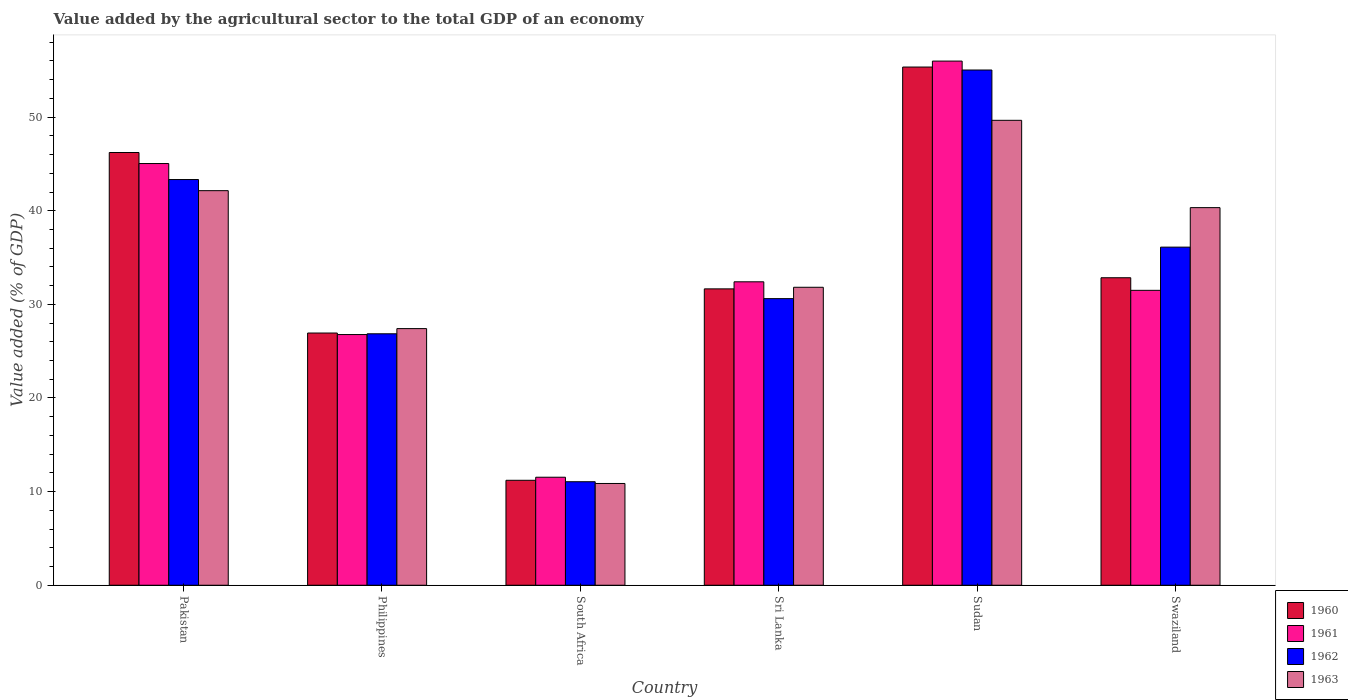What is the label of the 5th group of bars from the left?
Ensure brevity in your answer.  Sudan. What is the value added by the agricultural sector to the total GDP in 1960 in Swaziland?
Ensure brevity in your answer.  32.84. Across all countries, what is the maximum value added by the agricultural sector to the total GDP in 1962?
Offer a very short reply. 55.03. Across all countries, what is the minimum value added by the agricultural sector to the total GDP in 1960?
Make the answer very short. 11.21. In which country was the value added by the agricultural sector to the total GDP in 1960 maximum?
Give a very brief answer. Sudan. In which country was the value added by the agricultural sector to the total GDP in 1961 minimum?
Make the answer very short. South Africa. What is the total value added by the agricultural sector to the total GDP in 1962 in the graph?
Your response must be concise. 203.01. What is the difference between the value added by the agricultural sector to the total GDP in 1962 in Pakistan and that in Sri Lanka?
Provide a succinct answer. 12.72. What is the difference between the value added by the agricultural sector to the total GDP in 1962 in Pakistan and the value added by the agricultural sector to the total GDP in 1960 in Philippines?
Your response must be concise. 16.39. What is the average value added by the agricultural sector to the total GDP in 1960 per country?
Give a very brief answer. 34.04. What is the difference between the value added by the agricultural sector to the total GDP of/in 1963 and value added by the agricultural sector to the total GDP of/in 1960 in Philippines?
Keep it short and to the point. 0.47. What is the ratio of the value added by the agricultural sector to the total GDP in 1963 in South Africa to that in Sri Lanka?
Provide a short and direct response. 0.34. What is the difference between the highest and the second highest value added by the agricultural sector to the total GDP in 1962?
Offer a very short reply. 7.22. What is the difference between the highest and the lowest value added by the agricultural sector to the total GDP in 1961?
Your response must be concise. 44.45. In how many countries, is the value added by the agricultural sector to the total GDP in 1962 greater than the average value added by the agricultural sector to the total GDP in 1962 taken over all countries?
Make the answer very short. 3. Is the sum of the value added by the agricultural sector to the total GDP in 1963 in Pakistan and Sri Lanka greater than the maximum value added by the agricultural sector to the total GDP in 1961 across all countries?
Provide a short and direct response. Yes. Is it the case that in every country, the sum of the value added by the agricultural sector to the total GDP in 1963 and value added by the agricultural sector to the total GDP in 1962 is greater than the sum of value added by the agricultural sector to the total GDP in 1961 and value added by the agricultural sector to the total GDP in 1960?
Ensure brevity in your answer.  No. How many countries are there in the graph?
Keep it short and to the point. 6. Are the values on the major ticks of Y-axis written in scientific E-notation?
Make the answer very short. No. Does the graph contain any zero values?
Your response must be concise. No. How many legend labels are there?
Provide a short and direct response. 4. What is the title of the graph?
Keep it short and to the point. Value added by the agricultural sector to the total GDP of an economy. What is the label or title of the X-axis?
Keep it short and to the point. Country. What is the label or title of the Y-axis?
Your response must be concise. Value added (% of GDP). What is the Value added (% of GDP) of 1960 in Pakistan?
Provide a short and direct response. 46.22. What is the Value added (% of GDP) of 1961 in Pakistan?
Your answer should be compact. 45.04. What is the Value added (% of GDP) in 1962 in Pakistan?
Keep it short and to the point. 43.33. What is the Value added (% of GDP) in 1963 in Pakistan?
Keep it short and to the point. 42.15. What is the Value added (% of GDP) in 1960 in Philippines?
Offer a terse response. 26.94. What is the Value added (% of GDP) in 1961 in Philippines?
Keep it short and to the point. 26.78. What is the Value added (% of GDP) in 1962 in Philippines?
Make the answer very short. 26.86. What is the Value added (% of GDP) of 1963 in Philippines?
Your response must be concise. 27.41. What is the Value added (% of GDP) of 1960 in South Africa?
Your answer should be very brief. 11.21. What is the Value added (% of GDP) of 1961 in South Africa?
Give a very brief answer. 11.54. What is the Value added (% of GDP) in 1962 in South Africa?
Your answer should be very brief. 11.06. What is the Value added (% of GDP) in 1963 in South Africa?
Your answer should be very brief. 10.87. What is the Value added (% of GDP) of 1960 in Sri Lanka?
Make the answer very short. 31.66. What is the Value added (% of GDP) of 1961 in Sri Lanka?
Give a very brief answer. 32.41. What is the Value added (% of GDP) of 1962 in Sri Lanka?
Offer a very short reply. 30.61. What is the Value added (% of GDP) of 1963 in Sri Lanka?
Offer a very short reply. 31.83. What is the Value added (% of GDP) of 1960 in Sudan?
Provide a short and direct response. 55.35. What is the Value added (% of GDP) in 1961 in Sudan?
Make the answer very short. 55.99. What is the Value added (% of GDP) in 1962 in Sudan?
Your answer should be very brief. 55.03. What is the Value added (% of GDP) in 1963 in Sudan?
Ensure brevity in your answer.  49.66. What is the Value added (% of GDP) of 1960 in Swaziland?
Make the answer very short. 32.84. What is the Value added (% of GDP) of 1961 in Swaziland?
Ensure brevity in your answer.  31.5. What is the Value added (% of GDP) in 1962 in Swaziland?
Your answer should be very brief. 36.11. What is the Value added (% of GDP) of 1963 in Swaziland?
Offer a terse response. 40.33. Across all countries, what is the maximum Value added (% of GDP) in 1960?
Keep it short and to the point. 55.35. Across all countries, what is the maximum Value added (% of GDP) of 1961?
Give a very brief answer. 55.99. Across all countries, what is the maximum Value added (% of GDP) in 1962?
Provide a succinct answer. 55.03. Across all countries, what is the maximum Value added (% of GDP) of 1963?
Your response must be concise. 49.66. Across all countries, what is the minimum Value added (% of GDP) of 1960?
Ensure brevity in your answer.  11.21. Across all countries, what is the minimum Value added (% of GDP) in 1961?
Provide a succinct answer. 11.54. Across all countries, what is the minimum Value added (% of GDP) of 1962?
Your answer should be very brief. 11.06. Across all countries, what is the minimum Value added (% of GDP) of 1963?
Keep it short and to the point. 10.87. What is the total Value added (% of GDP) of 1960 in the graph?
Offer a very short reply. 204.22. What is the total Value added (% of GDP) in 1961 in the graph?
Keep it short and to the point. 203.26. What is the total Value added (% of GDP) in 1962 in the graph?
Provide a succinct answer. 203.01. What is the total Value added (% of GDP) of 1963 in the graph?
Provide a succinct answer. 202.25. What is the difference between the Value added (% of GDP) of 1960 in Pakistan and that in Philippines?
Your answer should be very brief. 19.28. What is the difference between the Value added (% of GDP) of 1961 in Pakistan and that in Philippines?
Offer a terse response. 18.27. What is the difference between the Value added (% of GDP) of 1962 in Pakistan and that in Philippines?
Give a very brief answer. 16.48. What is the difference between the Value added (% of GDP) in 1963 in Pakistan and that in Philippines?
Make the answer very short. 14.73. What is the difference between the Value added (% of GDP) of 1960 in Pakistan and that in South Africa?
Your response must be concise. 35.01. What is the difference between the Value added (% of GDP) in 1961 in Pakistan and that in South Africa?
Keep it short and to the point. 33.51. What is the difference between the Value added (% of GDP) of 1962 in Pakistan and that in South Africa?
Your answer should be very brief. 32.28. What is the difference between the Value added (% of GDP) in 1963 in Pakistan and that in South Africa?
Make the answer very short. 31.28. What is the difference between the Value added (% of GDP) in 1960 in Pakistan and that in Sri Lanka?
Ensure brevity in your answer.  14.56. What is the difference between the Value added (% of GDP) in 1961 in Pakistan and that in Sri Lanka?
Your answer should be compact. 12.63. What is the difference between the Value added (% of GDP) in 1962 in Pakistan and that in Sri Lanka?
Ensure brevity in your answer.  12.72. What is the difference between the Value added (% of GDP) in 1963 in Pakistan and that in Sri Lanka?
Offer a terse response. 10.32. What is the difference between the Value added (% of GDP) in 1960 in Pakistan and that in Sudan?
Offer a very short reply. -9.13. What is the difference between the Value added (% of GDP) of 1961 in Pakistan and that in Sudan?
Give a very brief answer. -10.94. What is the difference between the Value added (% of GDP) of 1962 in Pakistan and that in Sudan?
Your response must be concise. -11.7. What is the difference between the Value added (% of GDP) in 1963 in Pakistan and that in Sudan?
Make the answer very short. -7.51. What is the difference between the Value added (% of GDP) of 1960 in Pakistan and that in Swaziland?
Provide a short and direct response. 13.38. What is the difference between the Value added (% of GDP) in 1961 in Pakistan and that in Swaziland?
Your answer should be compact. 13.54. What is the difference between the Value added (% of GDP) in 1962 in Pakistan and that in Swaziland?
Make the answer very short. 7.22. What is the difference between the Value added (% of GDP) of 1963 in Pakistan and that in Swaziland?
Offer a terse response. 1.81. What is the difference between the Value added (% of GDP) of 1960 in Philippines and that in South Africa?
Your answer should be very brief. 15.73. What is the difference between the Value added (% of GDP) of 1961 in Philippines and that in South Africa?
Make the answer very short. 15.24. What is the difference between the Value added (% of GDP) of 1962 in Philippines and that in South Africa?
Provide a short and direct response. 15.8. What is the difference between the Value added (% of GDP) in 1963 in Philippines and that in South Africa?
Ensure brevity in your answer.  16.54. What is the difference between the Value added (% of GDP) of 1960 in Philippines and that in Sri Lanka?
Your answer should be very brief. -4.72. What is the difference between the Value added (% of GDP) in 1961 in Philippines and that in Sri Lanka?
Give a very brief answer. -5.63. What is the difference between the Value added (% of GDP) of 1962 in Philippines and that in Sri Lanka?
Your answer should be compact. -3.76. What is the difference between the Value added (% of GDP) in 1963 in Philippines and that in Sri Lanka?
Provide a succinct answer. -4.41. What is the difference between the Value added (% of GDP) of 1960 in Philippines and that in Sudan?
Provide a succinct answer. -28.41. What is the difference between the Value added (% of GDP) in 1961 in Philippines and that in Sudan?
Offer a terse response. -29.21. What is the difference between the Value added (% of GDP) of 1962 in Philippines and that in Sudan?
Give a very brief answer. -28.18. What is the difference between the Value added (% of GDP) in 1963 in Philippines and that in Sudan?
Provide a short and direct response. -22.25. What is the difference between the Value added (% of GDP) in 1960 in Philippines and that in Swaziland?
Give a very brief answer. -5.9. What is the difference between the Value added (% of GDP) in 1961 in Philippines and that in Swaziland?
Offer a very short reply. -4.72. What is the difference between the Value added (% of GDP) of 1962 in Philippines and that in Swaziland?
Your answer should be very brief. -9.26. What is the difference between the Value added (% of GDP) in 1963 in Philippines and that in Swaziland?
Ensure brevity in your answer.  -12.92. What is the difference between the Value added (% of GDP) of 1960 in South Africa and that in Sri Lanka?
Provide a short and direct response. -20.45. What is the difference between the Value added (% of GDP) of 1961 in South Africa and that in Sri Lanka?
Provide a short and direct response. -20.87. What is the difference between the Value added (% of GDP) of 1962 in South Africa and that in Sri Lanka?
Provide a succinct answer. -19.56. What is the difference between the Value added (% of GDP) of 1963 in South Africa and that in Sri Lanka?
Provide a succinct answer. -20.96. What is the difference between the Value added (% of GDP) of 1960 in South Africa and that in Sudan?
Ensure brevity in your answer.  -44.14. What is the difference between the Value added (% of GDP) of 1961 in South Africa and that in Sudan?
Your answer should be very brief. -44.45. What is the difference between the Value added (% of GDP) in 1962 in South Africa and that in Sudan?
Your response must be concise. -43.98. What is the difference between the Value added (% of GDP) of 1963 in South Africa and that in Sudan?
Make the answer very short. -38.79. What is the difference between the Value added (% of GDP) in 1960 in South Africa and that in Swaziland?
Keep it short and to the point. -21.63. What is the difference between the Value added (% of GDP) in 1961 in South Africa and that in Swaziland?
Offer a very short reply. -19.96. What is the difference between the Value added (% of GDP) of 1962 in South Africa and that in Swaziland?
Provide a short and direct response. -25.06. What is the difference between the Value added (% of GDP) of 1963 in South Africa and that in Swaziland?
Make the answer very short. -29.46. What is the difference between the Value added (% of GDP) in 1960 in Sri Lanka and that in Sudan?
Your response must be concise. -23.7. What is the difference between the Value added (% of GDP) of 1961 in Sri Lanka and that in Sudan?
Offer a terse response. -23.58. What is the difference between the Value added (% of GDP) in 1962 in Sri Lanka and that in Sudan?
Provide a short and direct response. -24.42. What is the difference between the Value added (% of GDP) of 1963 in Sri Lanka and that in Sudan?
Your answer should be compact. -17.83. What is the difference between the Value added (% of GDP) in 1960 in Sri Lanka and that in Swaziland?
Offer a terse response. -1.19. What is the difference between the Value added (% of GDP) in 1961 in Sri Lanka and that in Swaziland?
Give a very brief answer. 0.91. What is the difference between the Value added (% of GDP) of 1962 in Sri Lanka and that in Swaziland?
Ensure brevity in your answer.  -5.5. What is the difference between the Value added (% of GDP) in 1963 in Sri Lanka and that in Swaziland?
Make the answer very short. -8.51. What is the difference between the Value added (% of GDP) of 1960 in Sudan and that in Swaziland?
Keep it short and to the point. 22.51. What is the difference between the Value added (% of GDP) in 1961 in Sudan and that in Swaziland?
Provide a short and direct response. 24.49. What is the difference between the Value added (% of GDP) in 1962 in Sudan and that in Swaziland?
Ensure brevity in your answer.  18.92. What is the difference between the Value added (% of GDP) in 1963 in Sudan and that in Swaziland?
Your answer should be very brief. 9.32. What is the difference between the Value added (% of GDP) of 1960 in Pakistan and the Value added (% of GDP) of 1961 in Philippines?
Your response must be concise. 19.44. What is the difference between the Value added (% of GDP) in 1960 in Pakistan and the Value added (% of GDP) in 1962 in Philippines?
Give a very brief answer. 19.36. What is the difference between the Value added (% of GDP) in 1960 in Pakistan and the Value added (% of GDP) in 1963 in Philippines?
Make the answer very short. 18.81. What is the difference between the Value added (% of GDP) of 1961 in Pakistan and the Value added (% of GDP) of 1962 in Philippines?
Your answer should be compact. 18.19. What is the difference between the Value added (% of GDP) of 1961 in Pakistan and the Value added (% of GDP) of 1963 in Philippines?
Make the answer very short. 17.63. What is the difference between the Value added (% of GDP) of 1962 in Pakistan and the Value added (% of GDP) of 1963 in Philippines?
Offer a very short reply. 15.92. What is the difference between the Value added (% of GDP) of 1960 in Pakistan and the Value added (% of GDP) of 1961 in South Africa?
Offer a very short reply. 34.68. What is the difference between the Value added (% of GDP) of 1960 in Pakistan and the Value added (% of GDP) of 1962 in South Africa?
Ensure brevity in your answer.  35.16. What is the difference between the Value added (% of GDP) of 1960 in Pakistan and the Value added (% of GDP) of 1963 in South Africa?
Keep it short and to the point. 35.35. What is the difference between the Value added (% of GDP) of 1961 in Pakistan and the Value added (% of GDP) of 1962 in South Africa?
Your response must be concise. 33.99. What is the difference between the Value added (% of GDP) of 1961 in Pakistan and the Value added (% of GDP) of 1963 in South Africa?
Make the answer very short. 34.17. What is the difference between the Value added (% of GDP) in 1962 in Pakistan and the Value added (% of GDP) in 1963 in South Africa?
Provide a short and direct response. 32.46. What is the difference between the Value added (% of GDP) in 1960 in Pakistan and the Value added (% of GDP) in 1961 in Sri Lanka?
Your answer should be very brief. 13.81. What is the difference between the Value added (% of GDP) in 1960 in Pakistan and the Value added (% of GDP) in 1962 in Sri Lanka?
Make the answer very short. 15.61. What is the difference between the Value added (% of GDP) of 1960 in Pakistan and the Value added (% of GDP) of 1963 in Sri Lanka?
Give a very brief answer. 14.39. What is the difference between the Value added (% of GDP) of 1961 in Pakistan and the Value added (% of GDP) of 1962 in Sri Lanka?
Your response must be concise. 14.43. What is the difference between the Value added (% of GDP) in 1961 in Pakistan and the Value added (% of GDP) in 1963 in Sri Lanka?
Your answer should be compact. 13.22. What is the difference between the Value added (% of GDP) of 1962 in Pakistan and the Value added (% of GDP) of 1963 in Sri Lanka?
Provide a short and direct response. 11.51. What is the difference between the Value added (% of GDP) in 1960 in Pakistan and the Value added (% of GDP) in 1961 in Sudan?
Offer a very short reply. -9.77. What is the difference between the Value added (% of GDP) in 1960 in Pakistan and the Value added (% of GDP) in 1962 in Sudan?
Your answer should be compact. -8.81. What is the difference between the Value added (% of GDP) in 1960 in Pakistan and the Value added (% of GDP) in 1963 in Sudan?
Your answer should be very brief. -3.44. What is the difference between the Value added (% of GDP) of 1961 in Pakistan and the Value added (% of GDP) of 1962 in Sudan?
Keep it short and to the point. -9.99. What is the difference between the Value added (% of GDP) in 1961 in Pakistan and the Value added (% of GDP) in 1963 in Sudan?
Keep it short and to the point. -4.62. What is the difference between the Value added (% of GDP) in 1962 in Pakistan and the Value added (% of GDP) in 1963 in Sudan?
Offer a very short reply. -6.33. What is the difference between the Value added (% of GDP) in 1960 in Pakistan and the Value added (% of GDP) in 1961 in Swaziland?
Your answer should be compact. 14.72. What is the difference between the Value added (% of GDP) of 1960 in Pakistan and the Value added (% of GDP) of 1962 in Swaziland?
Give a very brief answer. 10.11. What is the difference between the Value added (% of GDP) of 1960 in Pakistan and the Value added (% of GDP) of 1963 in Swaziland?
Make the answer very short. 5.89. What is the difference between the Value added (% of GDP) in 1961 in Pakistan and the Value added (% of GDP) in 1962 in Swaziland?
Your answer should be very brief. 8.93. What is the difference between the Value added (% of GDP) of 1961 in Pakistan and the Value added (% of GDP) of 1963 in Swaziland?
Provide a succinct answer. 4.71. What is the difference between the Value added (% of GDP) of 1962 in Pakistan and the Value added (% of GDP) of 1963 in Swaziland?
Provide a short and direct response. 3. What is the difference between the Value added (% of GDP) of 1960 in Philippines and the Value added (% of GDP) of 1961 in South Africa?
Your answer should be compact. 15.4. What is the difference between the Value added (% of GDP) in 1960 in Philippines and the Value added (% of GDP) in 1962 in South Africa?
Keep it short and to the point. 15.88. What is the difference between the Value added (% of GDP) in 1960 in Philippines and the Value added (% of GDP) in 1963 in South Africa?
Ensure brevity in your answer.  16.07. What is the difference between the Value added (% of GDP) in 1961 in Philippines and the Value added (% of GDP) in 1962 in South Africa?
Provide a succinct answer. 15.72. What is the difference between the Value added (% of GDP) in 1961 in Philippines and the Value added (% of GDP) in 1963 in South Africa?
Provide a short and direct response. 15.91. What is the difference between the Value added (% of GDP) in 1962 in Philippines and the Value added (% of GDP) in 1963 in South Africa?
Make the answer very short. 15.99. What is the difference between the Value added (% of GDP) in 1960 in Philippines and the Value added (% of GDP) in 1961 in Sri Lanka?
Provide a short and direct response. -5.47. What is the difference between the Value added (% of GDP) in 1960 in Philippines and the Value added (% of GDP) in 1962 in Sri Lanka?
Make the answer very short. -3.67. What is the difference between the Value added (% of GDP) in 1960 in Philippines and the Value added (% of GDP) in 1963 in Sri Lanka?
Keep it short and to the point. -4.89. What is the difference between the Value added (% of GDP) of 1961 in Philippines and the Value added (% of GDP) of 1962 in Sri Lanka?
Provide a succinct answer. -3.84. What is the difference between the Value added (% of GDP) in 1961 in Philippines and the Value added (% of GDP) in 1963 in Sri Lanka?
Your answer should be compact. -5.05. What is the difference between the Value added (% of GDP) in 1962 in Philippines and the Value added (% of GDP) in 1963 in Sri Lanka?
Your response must be concise. -4.97. What is the difference between the Value added (% of GDP) in 1960 in Philippines and the Value added (% of GDP) in 1961 in Sudan?
Offer a terse response. -29.05. What is the difference between the Value added (% of GDP) in 1960 in Philippines and the Value added (% of GDP) in 1962 in Sudan?
Provide a succinct answer. -28.09. What is the difference between the Value added (% of GDP) in 1960 in Philippines and the Value added (% of GDP) in 1963 in Sudan?
Make the answer very short. -22.72. What is the difference between the Value added (% of GDP) of 1961 in Philippines and the Value added (% of GDP) of 1962 in Sudan?
Your answer should be very brief. -28.26. What is the difference between the Value added (% of GDP) of 1961 in Philippines and the Value added (% of GDP) of 1963 in Sudan?
Offer a very short reply. -22.88. What is the difference between the Value added (% of GDP) in 1962 in Philippines and the Value added (% of GDP) in 1963 in Sudan?
Make the answer very short. -22.8. What is the difference between the Value added (% of GDP) of 1960 in Philippines and the Value added (% of GDP) of 1961 in Swaziland?
Your response must be concise. -4.56. What is the difference between the Value added (% of GDP) of 1960 in Philippines and the Value added (% of GDP) of 1962 in Swaziland?
Make the answer very short. -9.17. What is the difference between the Value added (% of GDP) of 1960 in Philippines and the Value added (% of GDP) of 1963 in Swaziland?
Provide a short and direct response. -13.39. What is the difference between the Value added (% of GDP) in 1961 in Philippines and the Value added (% of GDP) in 1962 in Swaziland?
Keep it short and to the point. -9.34. What is the difference between the Value added (% of GDP) of 1961 in Philippines and the Value added (% of GDP) of 1963 in Swaziland?
Offer a very short reply. -13.56. What is the difference between the Value added (% of GDP) of 1962 in Philippines and the Value added (% of GDP) of 1963 in Swaziland?
Keep it short and to the point. -13.48. What is the difference between the Value added (% of GDP) of 1960 in South Africa and the Value added (% of GDP) of 1961 in Sri Lanka?
Provide a succinct answer. -21.2. What is the difference between the Value added (% of GDP) in 1960 in South Africa and the Value added (% of GDP) in 1962 in Sri Lanka?
Make the answer very short. -19.4. What is the difference between the Value added (% of GDP) in 1960 in South Africa and the Value added (% of GDP) in 1963 in Sri Lanka?
Provide a short and direct response. -20.62. What is the difference between the Value added (% of GDP) in 1961 in South Africa and the Value added (% of GDP) in 1962 in Sri Lanka?
Keep it short and to the point. -19.08. What is the difference between the Value added (% of GDP) in 1961 in South Africa and the Value added (% of GDP) in 1963 in Sri Lanka?
Offer a terse response. -20.29. What is the difference between the Value added (% of GDP) of 1962 in South Africa and the Value added (% of GDP) of 1963 in Sri Lanka?
Your answer should be compact. -20.77. What is the difference between the Value added (% of GDP) of 1960 in South Africa and the Value added (% of GDP) of 1961 in Sudan?
Your answer should be very brief. -44.78. What is the difference between the Value added (% of GDP) in 1960 in South Africa and the Value added (% of GDP) in 1962 in Sudan?
Ensure brevity in your answer.  -43.82. What is the difference between the Value added (% of GDP) of 1960 in South Africa and the Value added (% of GDP) of 1963 in Sudan?
Offer a very short reply. -38.45. What is the difference between the Value added (% of GDP) of 1961 in South Africa and the Value added (% of GDP) of 1962 in Sudan?
Your answer should be compact. -43.5. What is the difference between the Value added (% of GDP) in 1961 in South Africa and the Value added (% of GDP) in 1963 in Sudan?
Your answer should be compact. -38.12. What is the difference between the Value added (% of GDP) of 1962 in South Africa and the Value added (% of GDP) of 1963 in Sudan?
Make the answer very short. -38.6. What is the difference between the Value added (% of GDP) in 1960 in South Africa and the Value added (% of GDP) in 1961 in Swaziland?
Ensure brevity in your answer.  -20.29. What is the difference between the Value added (% of GDP) in 1960 in South Africa and the Value added (% of GDP) in 1962 in Swaziland?
Provide a succinct answer. -24.9. What is the difference between the Value added (% of GDP) of 1960 in South Africa and the Value added (% of GDP) of 1963 in Swaziland?
Offer a very short reply. -29.12. What is the difference between the Value added (% of GDP) in 1961 in South Africa and the Value added (% of GDP) in 1962 in Swaziland?
Your answer should be very brief. -24.58. What is the difference between the Value added (% of GDP) in 1961 in South Africa and the Value added (% of GDP) in 1963 in Swaziland?
Give a very brief answer. -28.8. What is the difference between the Value added (% of GDP) of 1962 in South Africa and the Value added (% of GDP) of 1963 in Swaziland?
Give a very brief answer. -29.28. What is the difference between the Value added (% of GDP) in 1960 in Sri Lanka and the Value added (% of GDP) in 1961 in Sudan?
Provide a succinct answer. -24.33. What is the difference between the Value added (% of GDP) in 1960 in Sri Lanka and the Value added (% of GDP) in 1962 in Sudan?
Your answer should be very brief. -23.38. What is the difference between the Value added (% of GDP) of 1960 in Sri Lanka and the Value added (% of GDP) of 1963 in Sudan?
Ensure brevity in your answer.  -18. What is the difference between the Value added (% of GDP) in 1961 in Sri Lanka and the Value added (% of GDP) in 1962 in Sudan?
Ensure brevity in your answer.  -22.62. What is the difference between the Value added (% of GDP) in 1961 in Sri Lanka and the Value added (% of GDP) in 1963 in Sudan?
Offer a terse response. -17.25. What is the difference between the Value added (% of GDP) of 1962 in Sri Lanka and the Value added (% of GDP) of 1963 in Sudan?
Your answer should be compact. -19.04. What is the difference between the Value added (% of GDP) of 1960 in Sri Lanka and the Value added (% of GDP) of 1961 in Swaziland?
Provide a succinct answer. 0.16. What is the difference between the Value added (% of GDP) of 1960 in Sri Lanka and the Value added (% of GDP) of 1962 in Swaziland?
Your answer should be compact. -4.46. What is the difference between the Value added (% of GDP) in 1960 in Sri Lanka and the Value added (% of GDP) in 1963 in Swaziland?
Your answer should be very brief. -8.68. What is the difference between the Value added (% of GDP) in 1961 in Sri Lanka and the Value added (% of GDP) in 1962 in Swaziland?
Ensure brevity in your answer.  -3.7. What is the difference between the Value added (% of GDP) in 1961 in Sri Lanka and the Value added (% of GDP) in 1963 in Swaziland?
Ensure brevity in your answer.  -7.92. What is the difference between the Value added (% of GDP) of 1962 in Sri Lanka and the Value added (% of GDP) of 1963 in Swaziland?
Ensure brevity in your answer.  -9.72. What is the difference between the Value added (% of GDP) of 1960 in Sudan and the Value added (% of GDP) of 1961 in Swaziland?
Your answer should be very brief. 23.85. What is the difference between the Value added (% of GDP) in 1960 in Sudan and the Value added (% of GDP) in 1962 in Swaziland?
Provide a succinct answer. 19.24. What is the difference between the Value added (% of GDP) of 1960 in Sudan and the Value added (% of GDP) of 1963 in Swaziland?
Give a very brief answer. 15.02. What is the difference between the Value added (% of GDP) of 1961 in Sudan and the Value added (% of GDP) of 1962 in Swaziland?
Keep it short and to the point. 19.87. What is the difference between the Value added (% of GDP) in 1961 in Sudan and the Value added (% of GDP) in 1963 in Swaziland?
Offer a terse response. 15.65. What is the difference between the Value added (% of GDP) in 1962 in Sudan and the Value added (% of GDP) in 1963 in Swaziland?
Your answer should be very brief. 14.7. What is the average Value added (% of GDP) of 1960 per country?
Provide a succinct answer. 34.04. What is the average Value added (% of GDP) in 1961 per country?
Your response must be concise. 33.88. What is the average Value added (% of GDP) in 1962 per country?
Ensure brevity in your answer.  33.83. What is the average Value added (% of GDP) of 1963 per country?
Provide a succinct answer. 33.71. What is the difference between the Value added (% of GDP) in 1960 and Value added (% of GDP) in 1961 in Pakistan?
Provide a short and direct response. 1.18. What is the difference between the Value added (% of GDP) of 1960 and Value added (% of GDP) of 1962 in Pakistan?
Keep it short and to the point. 2.89. What is the difference between the Value added (% of GDP) in 1960 and Value added (% of GDP) in 1963 in Pakistan?
Make the answer very short. 4.07. What is the difference between the Value added (% of GDP) in 1961 and Value added (% of GDP) in 1962 in Pakistan?
Keep it short and to the point. 1.71. What is the difference between the Value added (% of GDP) in 1961 and Value added (% of GDP) in 1963 in Pakistan?
Keep it short and to the point. 2.9. What is the difference between the Value added (% of GDP) in 1962 and Value added (% of GDP) in 1963 in Pakistan?
Give a very brief answer. 1.19. What is the difference between the Value added (% of GDP) in 1960 and Value added (% of GDP) in 1961 in Philippines?
Ensure brevity in your answer.  0.16. What is the difference between the Value added (% of GDP) in 1960 and Value added (% of GDP) in 1962 in Philippines?
Your answer should be compact. 0.08. What is the difference between the Value added (% of GDP) in 1960 and Value added (% of GDP) in 1963 in Philippines?
Keep it short and to the point. -0.47. What is the difference between the Value added (% of GDP) in 1961 and Value added (% of GDP) in 1962 in Philippines?
Give a very brief answer. -0.08. What is the difference between the Value added (% of GDP) of 1961 and Value added (% of GDP) of 1963 in Philippines?
Your answer should be compact. -0.64. What is the difference between the Value added (% of GDP) in 1962 and Value added (% of GDP) in 1963 in Philippines?
Make the answer very short. -0.55. What is the difference between the Value added (% of GDP) in 1960 and Value added (% of GDP) in 1961 in South Africa?
Keep it short and to the point. -0.33. What is the difference between the Value added (% of GDP) in 1960 and Value added (% of GDP) in 1962 in South Africa?
Give a very brief answer. 0.15. What is the difference between the Value added (% of GDP) of 1960 and Value added (% of GDP) of 1963 in South Africa?
Provide a short and direct response. 0.34. What is the difference between the Value added (% of GDP) of 1961 and Value added (% of GDP) of 1962 in South Africa?
Keep it short and to the point. 0.48. What is the difference between the Value added (% of GDP) in 1961 and Value added (% of GDP) in 1963 in South Africa?
Provide a succinct answer. 0.67. What is the difference between the Value added (% of GDP) in 1962 and Value added (% of GDP) in 1963 in South Africa?
Provide a succinct answer. 0.19. What is the difference between the Value added (% of GDP) of 1960 and Value added (% of GDP) of 1961 in Sri Lanka?
Ensure brevity in your answer.  -0.76. What is the difference between the Value added (% of GDP) of 1960 and Value added (% of GDP) of 1962 in Sri Lanka?
Make the answer very short. 1.04. What is the difference between the Value added (% of GDP) of 1960 and Value added (% of GDP) of 1963 in Sri Lanka?
Ensure brevity in your answer.  -0.17. What is the difference between the Value added (% of GDP) in 1961 and Value added (% of GDP) in 1962 in Sri Lanka?
Give a very brief answer. 1.8. What is the difference between the Value added (% of GDP) in 1961 and Value added (% of GDP) in 1963 in Sri Lanka?
Your response must be concise. 0.59. What is the difference between the Value added (% of GDP) in 1962 and Value added (% of GDP) in 1963 in Sri Lanka?
Provide a short and direct response. -1.21. What is the difference between the Value added (% of GDP) in 1960 and Value added (% of GDP) in 1961 in Sudan?
Keep it short and to the point. -0.64. What is the difference between the Value added (% of GDP) of 1960 and Value added (% of GDP) of 1962 in Sudan?
Ensure brevity in your answer.  0.32. What is the difference between the Value added (% of GDP) of 1960 and Value added (% of GDP) of 1963 in Sudan?
Your answer should be compact. 5.69. What is the difference between the Value added (% of GDP) in 1961 and Value added (% of GDP) in 1962 in Sudan?
Offer a terse response. 0.95. What is the difference between the Value added (% of GDP) of 1961 and Value added (% of GDP) of 1963 in Sudan?
Provide a short and direct response. 6.33. What is the difference between the Value added (% of GDP) of 1962 and Value added (% of GDP) of 1963 in Sudan?
Give a very brief answer. 5.37. What is the difference between the Value added (% of GDP) in 1960 and Value added (% of GDP) in 1961 in Swaziland?
Your response must be concise. 1.35. What is the difference between the Value added (% of GDP) of 1960 and Value added (% of GDP) of 1962 in Swaziland?
Offer a terse response. -3.27. What is the difference between the Value added (% of GDP) of 1960 and Value added (% of GDP) of 1963 in Swaziland?
Your answer should be very brief. -7.49. What is the difference between the Value added (% of GDP) in 1961 and Value added (% of GDP) in 1962 in Swaziland?
Your answer should be very brief. -4.61. What is the difference between the Value added (% of GDP) in 1961 and Value added (% of GDP) in 1963 in Swaziland?
Provide a succinct answer. -8.83. What is the difference between the Value added (% of GDP) in 1962 and Value added (% of GDP) in 1963 in Swaziland?
Make the answer very short. -4.22. What is the ratio of the Value added (% of GDP) in 1960 in Pakistan to that in Philippines?
Your response must be concise. 1.72. What is the ratio of the Value added (% of GDP) of 1961 in Pakistan to that in Philippines?
Make the answer very short. 1.68. What is the ratio of the Value added (% of GDP) in 1962 in Pakistan to that in Philippines?
Your answer should be very brief. 1.61. What is the ratio of the Value added (% of GDP) of 1963 in Pakistan to that in Philippines?
Offer a terse response. 1.54. What is the ratio of the Value added (% of GDP) of 1960 in Pakistan to that in South Africa?
Your answer should be compact. 4.12. What is the ratio of the Value added (% of GDP) in 1961 in Pakistan to that in South Africa?
Keep it short and to the point. 3.9. What is the ratio of the Value added (% of GDP) in 1962 in Pakistan to that in South Africa?
Provide a short and direct response. 3.92. What is the ratio of the Value added (% of GDP) of 1963 in Pakistan to that in South Africa?
Provide a succinct answer. 3.88. What is the ratio of the Value added (% of GDP) in 1960 in Pakistan to that in Sri Lanka?
Give a very brief answer. 1.46. What is the ratio of the Value added (% of GDP) in 1961 in Pakistan to that in Sri Lanka?
Offer a terse response. 1.39. What is the ratio of the Value added (% of GDP) in 1962 in Pakistan to that in Sri Lanka?
Ensure brevity in your answer.  1.42. What is the ratio of the Value added (% of GDP) in 1963 in Pakistan to that in Sri Lanka?
Provide a succinct answer. 1.32. What is the ratio of the Value added (% of GDP) of 1960 in Pakistan to that in Sudan?
Provide a short and direct response. 0.83. What is the ratio of the Value added (% of GDP) of 1961 in Pakistan to that in Sudan?
Make the answer very short. 0.8. What is the ratio of the Value added (% of GDP) in 1962 in Pakistan to that in Sudan?
Your answer should be compact. 0.79. What is the ratio of the Value added (% of GDP) of 1963 in Pakistan to that in Sudan?
Your answer should be very brief. 0.85. What is the ratio of the Value added (% of GDP) in 1960 in Pakistan to that in Swaziland?
Offer a terse response. 1.41. What is the ratio of the Value added (% of GDP) in 1961 in Pakistan to that in Swaziland?
Offer a terse response. 1.43. What is the ratio of the Value added (% of GDP) in 1962 in Pakistan to that in Swaziland?
Offer a terse response. 1.2. What is the ratio of the Value added (% of GDP) of 1963 in Pakistan to that in Swaziland?
Offer a terse response. 1.04. What is the ratio of the Value added (% of GDP) in 1960 in Philippines to that in South Africa?
Make the answer very short. 2.4. What is the ratio of the Value added (% of GDP) in 1961 in Philippines to that in South Africa?
Provide a succinct answer. 2.32. What is the ratio of the Value added (% of GDP) of 1962 in Philippines to that in South Africa?
Ensure brevity in your answer.  2.43. What is the ratio of the Value added (% of GDP) of 1963 in Philippines to that in South Africa?
Your answer should be compact. 2.52. What is the ratio of the Value added (% of GDP) of 1960 in Philippines to that in Sri Lanka?
Your answer should be very brief. 0.85. What is the ratio of the Value added (% of GDP) in 1961 in Philippines to that in Sri Lanka?
Your answer should be very brief. 0.83. What is the ratio of the Value added (% of GDP) of 1962 in Philippines to that in Sri Lanka?
Keep it short and to the point. 0.88. What is the ratio of the Value added (% of GDP) of 1963 in Philippines to that in Sri Lanka?
Offer a very short reply. 0.86. What is the ratio of the Value added (% of GDP) of 1960 in Philippines to that in Sudan?
Give a very brief answer. 0.49. What is the ratio of the Value added (% of GDP) of 1961 in Philippines to that in Sudan?
Provide a succinct answer. 0.48. What is the ratio of the Value added (% of GDP) in 1962 in Philippines to that in Sudan?
Your answer should be compact. 0.49. What is the ratio of the Value added (% of GDP) of 1963 in Philippines to that in Sudan?
Your answer should be compact. 0.55. What is the ratio of the Value added (% of GDP) in 1960 in Philippines to that in Swaziland?
Ensure brevity in your answer.  0.82. What is the ratio of the Value added (% of GDP) of 1961 in Philippines to that in Swaziland?
Make the answer very short. 0.85. What is the ratio of the Value added (% of GDP) in 1962 in Philippines to that in Swaziland?
Offer a terse response. 0.74. What is the ratio of the Value added (% of GDP) in 1963 in Philippines to that in Swaziland?
Give a very brief answer. 0.68. What is the ratio of the Value added (% of GDP) of 1960 in South Africa to that in Sri Lanka?
Offer a terse response. 0.35. What is the ratio of the Value added (% of GDP) of 1961 in South Africa to that in Sri Lanka?
Make the answer very short. 0.36. What is the ratio of the Value added (% of GDP) of 1962 in South Africa to that in Sri Lanka?
Offer a very short reply. 0.36. What is the ratio of the Value added (% of GDP) of 1963 in South Africa to that in Sri Lanka?
Make the answer very short. 0.34. What is the ratio of the Value added (% of GDP) in 1960 in South Africa to that in Sudan?
Provide a succinct answer. 0.2. What is the ratio of the Value added (% of GDP) of 1961 in South Africa to that in Sudan?
Provide a short and direct response. 0.21. What is the ratio of the Value added (% of GDP) in 1962 in South Africa to that in Sudan?
Your answer should be compact. 0.2. What is the ratio of the Value added (% of GDP) in 1963 in South Africa to that in Sudan?
Provide a short and direct response. 0.22. What is the ratio of the Value added (% of GDP) of 1960 in South Africa to that in Swaziland?
Offer a very short reply. 0.34. What is the ratio of the Value added (% of GDP) of 1961 in South Africa to that in Swaziland?
Offer a terse response. 0.37. What is the ratio of the Value added (% of GDP) in 1962 in South Africa to that in Swaziland?
Your answer should be very brief. 0.31. What is the ratio of the Value added (% of GDP) in 1963 in South Africa to that in Swaziland?
Ensure brevity in your answer.  0.27. What is the ratio of the Value added (% of GDP) in 1960 in Sri Lanka to that in Sudan?
Your answer should be very brief. 0.57. What is the ratio of the Value added (% of GDP) in 1961 in Sri Lanka to that in Sudan?
Make the answer very short. 0.58. What is the ratio of the Value added (% of GDP) in 1962 in Sri Lanka to that in Sudan?
Provide a succinct answer. 0.56. What is the ratio of the Value added (% of GDP) of 1963 in Sri Lanka to that in Sudan?
Make the answer very short. 0.64. What is the ratio of the Value added (% of GDP) of 1960 in Sri Lanka to that in Swaziland?
Your answer should be very brief. 0.96. What is the ratio of the Value added (% of GDP) in 1961 in Sri Lanka to that in Swaziland?
Provide a succinct answer. 1.03. What is the ratio of the Value added (% of GDP) of 1962 in Sri Lanka to that in Swaziland?
Ensure brevity in your answer.  0.85. What is the ratio of the Value added (% of GDP) of 1963 in Sri Lanka to that in Swaziland?
Your answer should be very brief. 0.79. What is the ratio of the Value added (% of GDP) in 1960 in Sudan to that in Swaziland?
Make the answer very short. 1.69. What is the ratio of the Value added (% of GDP) of 1961 in Sudan to that in Swaziland?
Your answer should be very brief. 1.78. What is the ratio of the Value added (% of GDP) of 1962 in Sudan to that in Swaziland?
Your answer should be very brief. 1.52. What is the ratio of the Value added (% of GDP) in 1963 in Sudan to that in Swaziland?
Provide a succinct answer. 1.23. What is the difference between the highest and the second highest Value added (% of GDP) in 1960?
Provide a succinct answer. 9.13. What is the difference between the highest and the second highest Value added (% of GDP) of 1961?
Provide a short and direct response. 10.94. What is the difference between the highest and the second highest Value added (% of GDP) in 1962?
Provide a succinct answer. 11.7. What is the difference between the highest and the second highest Value added (% of GDP) of 1963?
Offer a very short reply. 7.51. What is the difference between the highest and the lowest Value added (% of GDP) of 1960?
Ensure brevity in your answer.  44.14. What is the difference between the highest and the lowest Value added (% of GDP) in 1961?
Your answer should be very brief. 44.45. What is the difference between the highest and the lowest Value added (% of GDP) of 1962?
Provide a short and direct response. 43.98. What is the difference between the highest and the lowest Value added (% of GDP) in 1963?
Offer a very short reply. 38.79. 